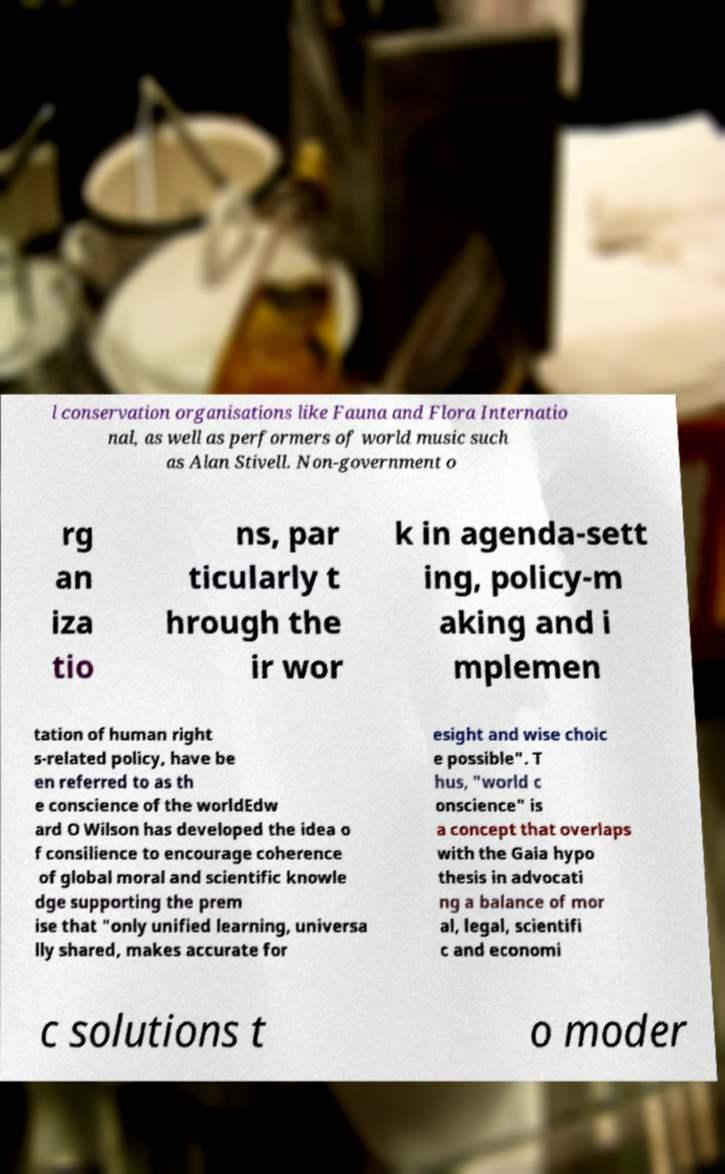There's text embedded in this image that I need extracted. Can you transcribe it verbatim? l conservation organisations like Fauna and Flora Internatio nal, as well as performers of world music such as Alan Stivell. Non-government o rg an iza tio ns, par ticularly t hrough the ir wor k in agenda-sett ing, policy-m aking and i mplemen tation of human right s-related policy, have be en referred to as th e conscience of the worldEdw ard O Wilson has developed the idea o f consilience to encourage coherence of global moral and scientific knowle dge supporting the prem ise that "only unified learning, universa lly shared, makes accurate for esight and wise choic e possible". T hus, "world c onscience" is a concept that overlaps with the Gaia hypo thesis in advocati ng a balance of mor al, legal, scientifi c and economi c solutions t o moder 